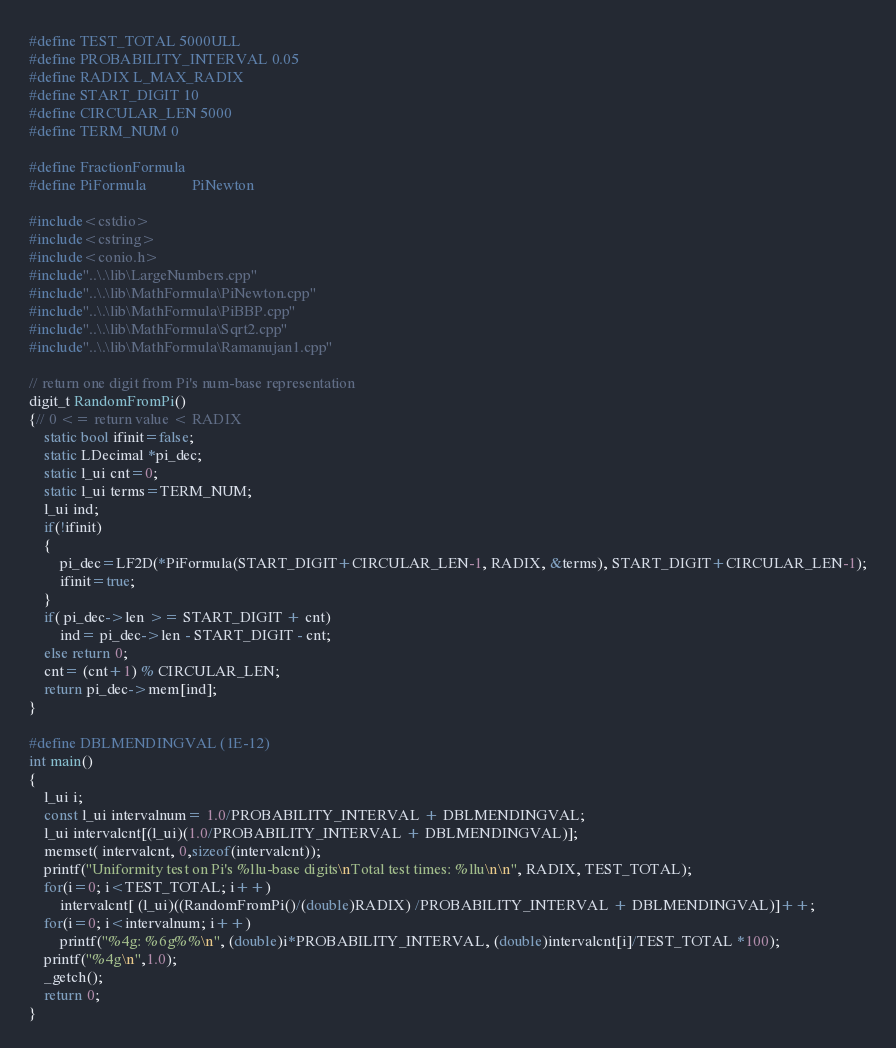Convert code to text. <code><loc_0><loc_0><loc_500><loc_500><_C++_>#define TEST_TOTAL 5000ULL
#define PROBABILITY_INTERVAL 0.05
#define RADIX L_MAX_RADIX
#define START_DIGIT 10
#define CIRCULAR_LEN 5000
#define TERM_NUM 0

#define FractionFormula
#define PiFormula			PiNewton

#include<cstdio>
#include<cstring>
#include<conio.h>
#include"..\.\lib\LargeNumbers.cpp"
#include"..\.\lib\MathFormula\PiNewton.cpp"
#include"..\.\lib\MathFormula\PiBBP.cpp"
#include"..\.\lib\MathFormula\Sqrt2.cpp"
#include"..\.\lib\MathFormula\Ramanujan1.cpp"

// return one digit from Pi's num-base representation
digit_t RandomFromPi()
{// 0 <= return value < RADIX
	static bool ifinit=false;
	static LDecimal *pi_dec;
	static l_ui cnt=0;
	static l_ui terms=TERM_NUM;
	l_ui ind;
	if(!ifinit)
	{
		pi_dec=LF2D(*PiFormula(START_DIGIT+CIRCULAR_LEN-1, RADIX, &terms), START_DIGIT+CIRCULAR_LEN-1);
		ifinit=true;
	}
	if( pi_dec->len >= START_DIGIT + cnt)
		ind= pi_dec->len - START_DIGIT - cnt;
	else return 0;
	cnt= (cnt+1) % CIRCULAR_LEN;
	return pi_dec->mem[ind];
}

#define DBLMENDINGVAL (1E-12)
int main()
{
	l_ui i;
	const l_ui intervalnum= 1.0/PROBABILITY_INTERVAL + DBLMENDINGVAL;
	l_ui intervalcnt[(l_ui)(1.0/PROBABILITY_INTERVAL + DBLMENDINGVAL)];
	memset( intervalcnt, 0,sizeof(intervalcnt));
	printf("Uniformity test on Pi's %llu-base digits\nTotal test times: %llu\n\n", RADIX, TEST_TOTAL);
	for(i=0; i<TEST_TOTAL; i++)
		intervalcnt[ (l_ui)((RandomFromPi()/(double)RADIX) /PROBABILITY_INTERVAL + DBLMENDINGVAL)]++;
	for(i=0; i<intervalnum; i++)
		printf("%4g: %6g%%\n", (double)i*PROBABILITY_INTERVAL, (double)intervalcnt[i]/TEST_TOTAL *100);
	printf("%4g\n",1.0);
	_getch();
	return 0;
}
</code> 